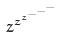Convert formula to latex. <formula><loc_0><loc_0><loc_500><loc_500>z ^ { z ^ { z ^ { - ^ { - ^ { - } } } } }</formula> 